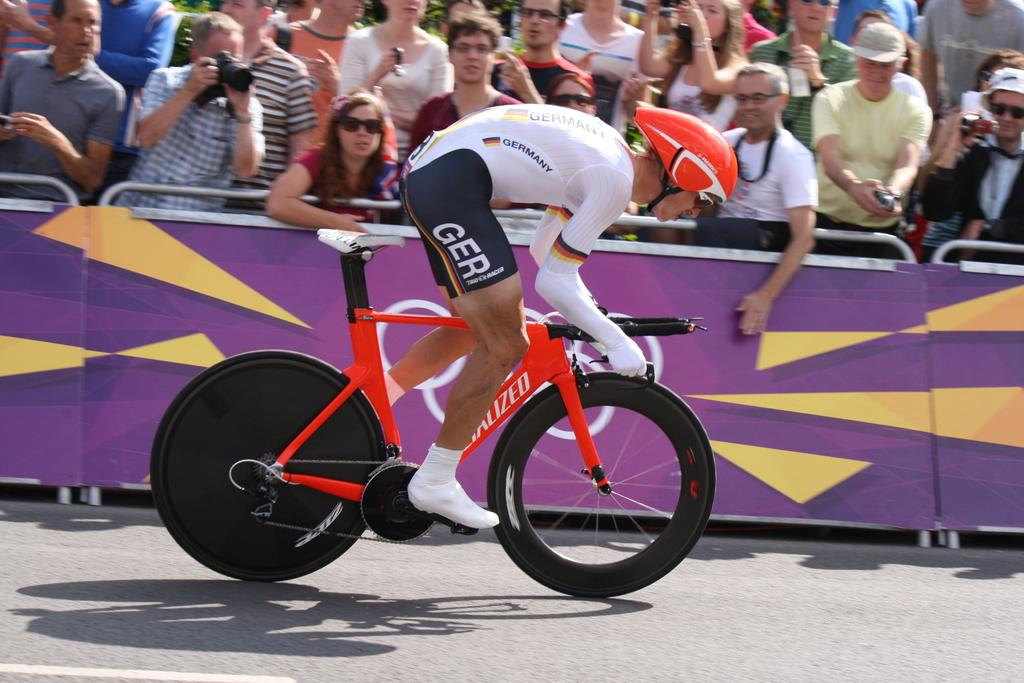What is the man in the image wearing on his head? The man is wearing a helmet in the image. What activity is the man with the helmet engaged in? The man is riding a bicycle in the image. Are there any other people present in the image? Yes, there are people in the image who can be considered as an audience. Who might be capturing the scene in the image? There is a man holding a camera in the image. Can you tell me how many tigers are present in the image? There are no tigers present in the image. What type of discussion is taking place between the man with the helmet and the audience? There is no discussion taking place in the image; it is focused on the man riding a bicycle. 